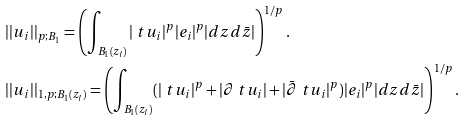Convert formula to latex. <formula><loc_0><loc_0><loc_500><loc_500>& | | u _ { i } | | _ { p ; B _ { 1 } } = \left ( \int _ { B _ { 1 } ( z _ { l } ) } | \ t u _ { i } | ^ { p } | e _ { i } | ^ { p } | d z d \bar { z } | \right ) ^ { 1 / p } . \\ & | | u _ { i } | | _ { 1 , p ; B _ { 1 } ( z _ { l } ) } = \left ( \int _ { B _ { 1 } ( z _ { l } ) } ( | \ t u _ { i } | ^ { p } + | \partial \ t u _ { i } | + | \bar { \partial } \ t u _ { i } | ^ { p } ) | e _ { i } | ^ { p } | d z d \bar { z } | \right ) ^ { 1 / p } .</formula> 